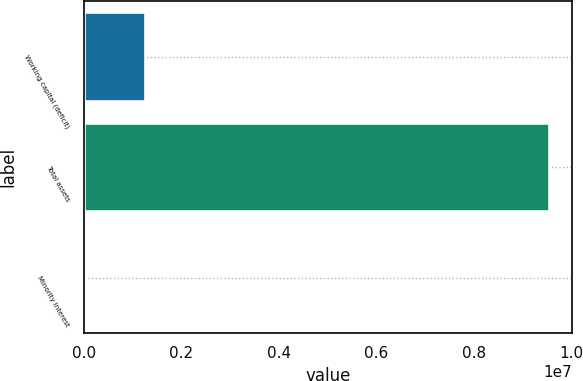Convert chart. <chart><loc_0><loc_0><loc_500><loc_500><bar_chart><fcel>Working capital (deficit)<fcel>Total assets<fcel>Minority interest<nl><fcel>1.26368e+06<fcel>9.53719e+06<fcel>18435<nl></chart> 